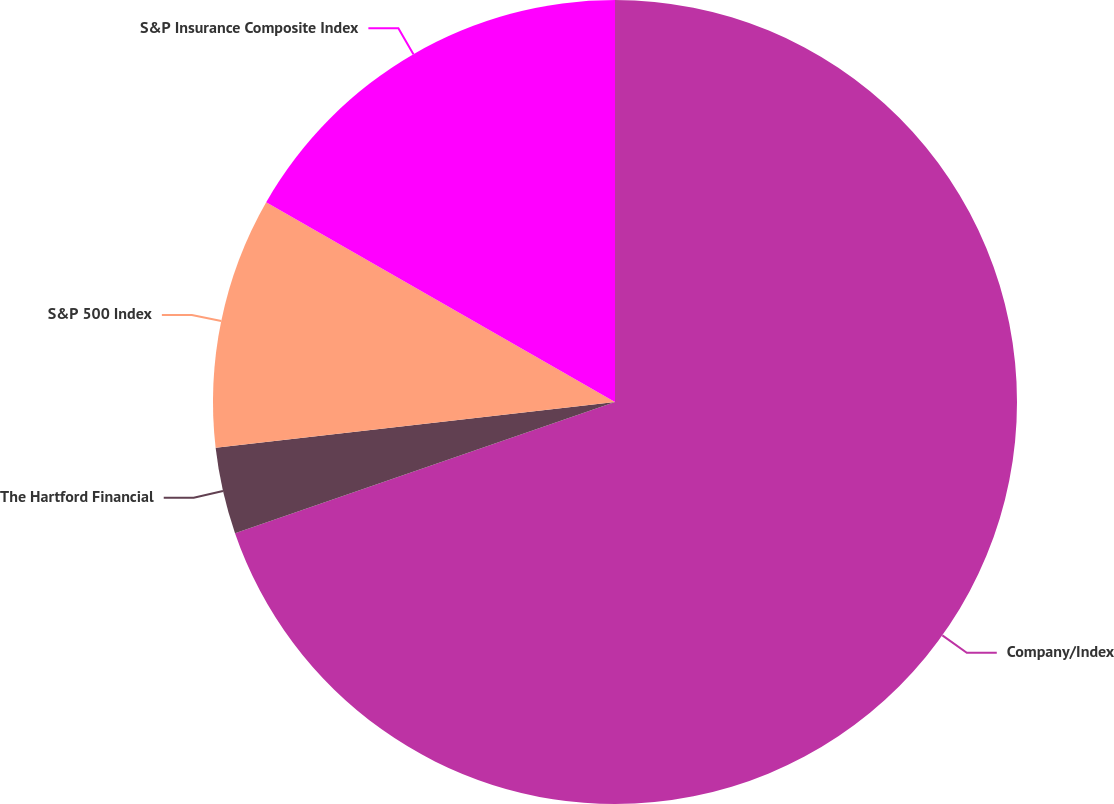Convert chart. <chart><loc_0><loc_0><loc_500><loc_500><pie_chart><fcel>Company/Index<fcel>The Hartford Financial<fcel>S&P 500 Index<fcel>S&P Insurance Composite Index<nl><fcel>69.71%<fcel>3.47%<fcel>10.1%<fcel>16.72%<nl></chart> 